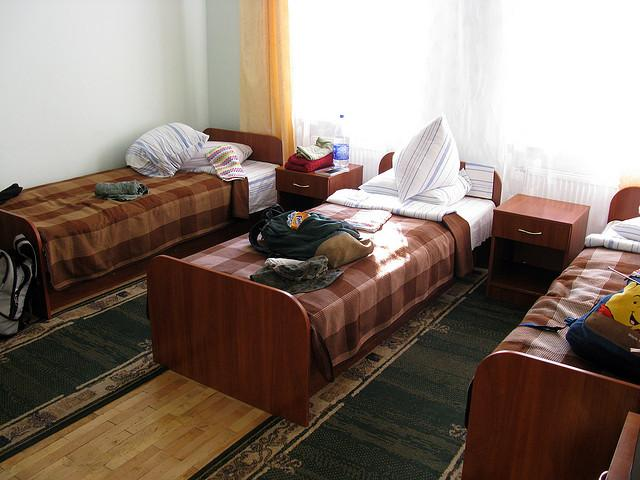What color is the face of the cartoon character on the backpack on the far right bed? yellow 